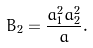Convert formula to latex. <formula><loc_0><loc_0><loc_500><loc_500>B _ { 2 } = \frac { a _ { 1 } ^ { 2 } a _ { 2 } ^ { 2 } } { a } .</formula> 